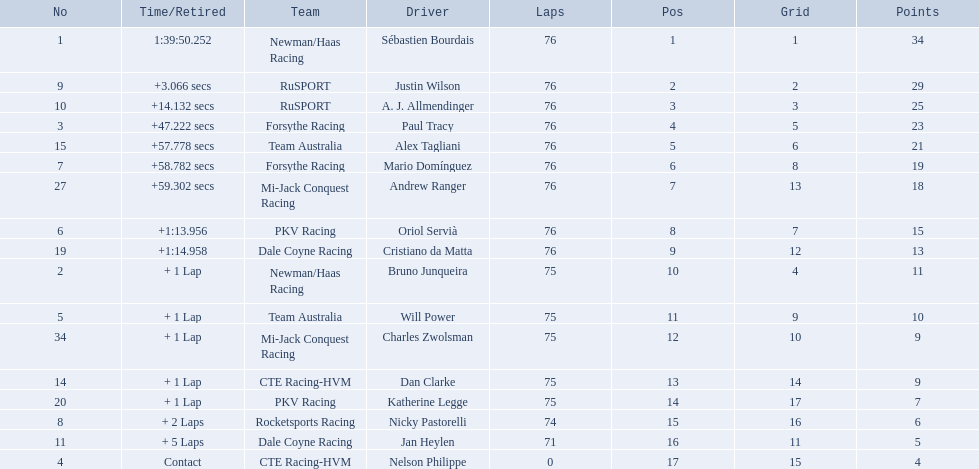Which drivers completed all 76 laps? Sébastien Bourdais, Justin Wilson, A. J. Allmendinger, Paul Tracy, Alex Tagliani, Mario Domínguez, Andrew Ranger, Oriol Servià, Cristiano da Matta. Of these drivers, which ones finished less than a minute behind first place? Paul Tracy, Alex Tagliani, Mario Domínguez, Andrew Ranger. Of these drivers, which ones finished with a time less than 50 seconds behind first place? Justin Wilson, A. J. Allmendinger, Paul Tracy. Of these three drivers, who finished last? Paul Tracy. 